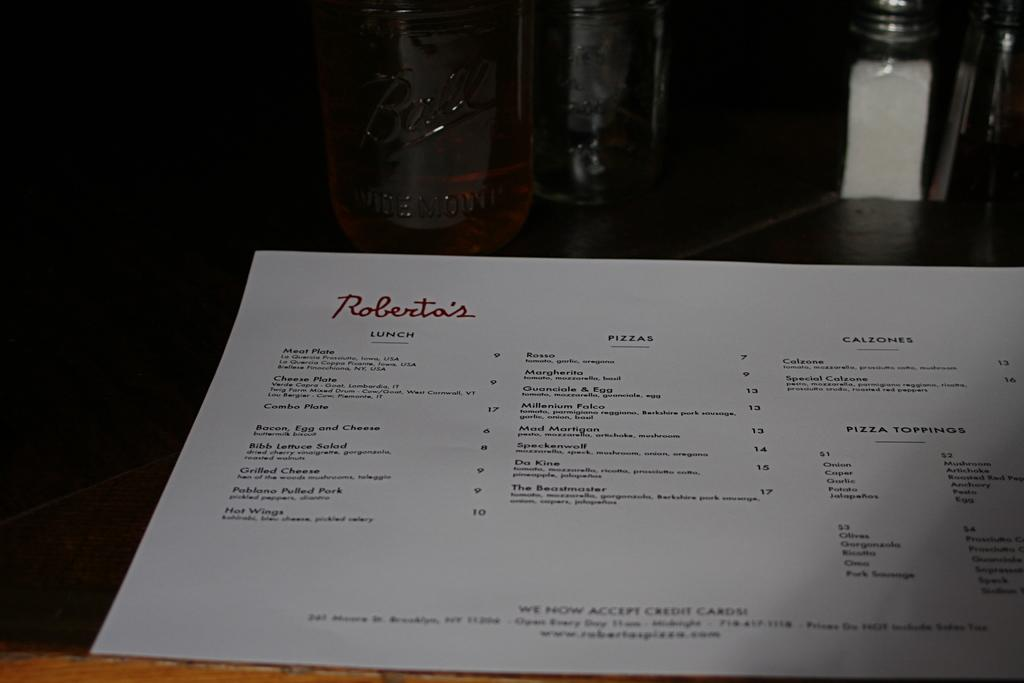What is the focus of the image? The image is zoomed in. What can be seen in the foreground of the image? There is a paper in the foreground of the image. What is written on the paper? The paper has text on it. What can be seen in the background of the image? There are glass objects in the background of the image. Where are the glass objects placed? The glass objects are placed on a table. What type of suit is the person wearing in the image? There is no person present in the image, and therefore no suit can be observed. What is the person learning in the image? There is no person present in the image, and therefore no learning activity can be observed. 